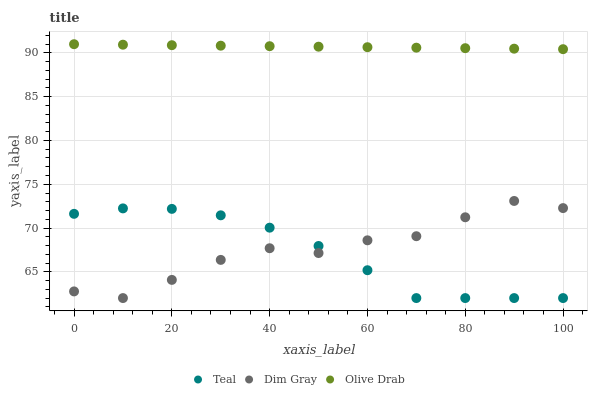Does Teal have the minimum area under the curve?
Answer yes or no. Yes. Does Olive Drab have the maximum area under the curve?
Answer yes or no. Yes. Does Olive Drab have the minimum area under the curve?
Answer yes or no. No. Does Teal have the maximum area under the curve?
Answer yes or no. No. Is Olive Drab the smoothest?
Answer yes or no. Yes. Is Dim Gray the roughest?
Answer yes or no. Yes. Is Teal the smoothest?
Answer yes or no. No. Is Teal the roughest?
Answer yes or no. No. Does Dim Gray have the lowest value?
Answer yes or no. Yes. Does Olive Drab have the lowest value?
Answer yes or no. No. Does Olive Drab have the highest value?
Answer yes or no. Yes. Does Teal have the highest value?
Answer yes or no. No. Is Dim Gray less than Olive Drab?
Answer yes or no. Yes. Is Olive Drab greater than Dim Gray?
Answer yes or no. Yes. Does Dim Gray intersect Teal?
Answer yes or no. Yes. Is Dim Gray less than Teal?
Answer yes or no. No. Is Dim Gray greater than Teal?
Answer yes or no. No. Does Dim Gray intersect Olive Drab?
Answer yes or no. No. 